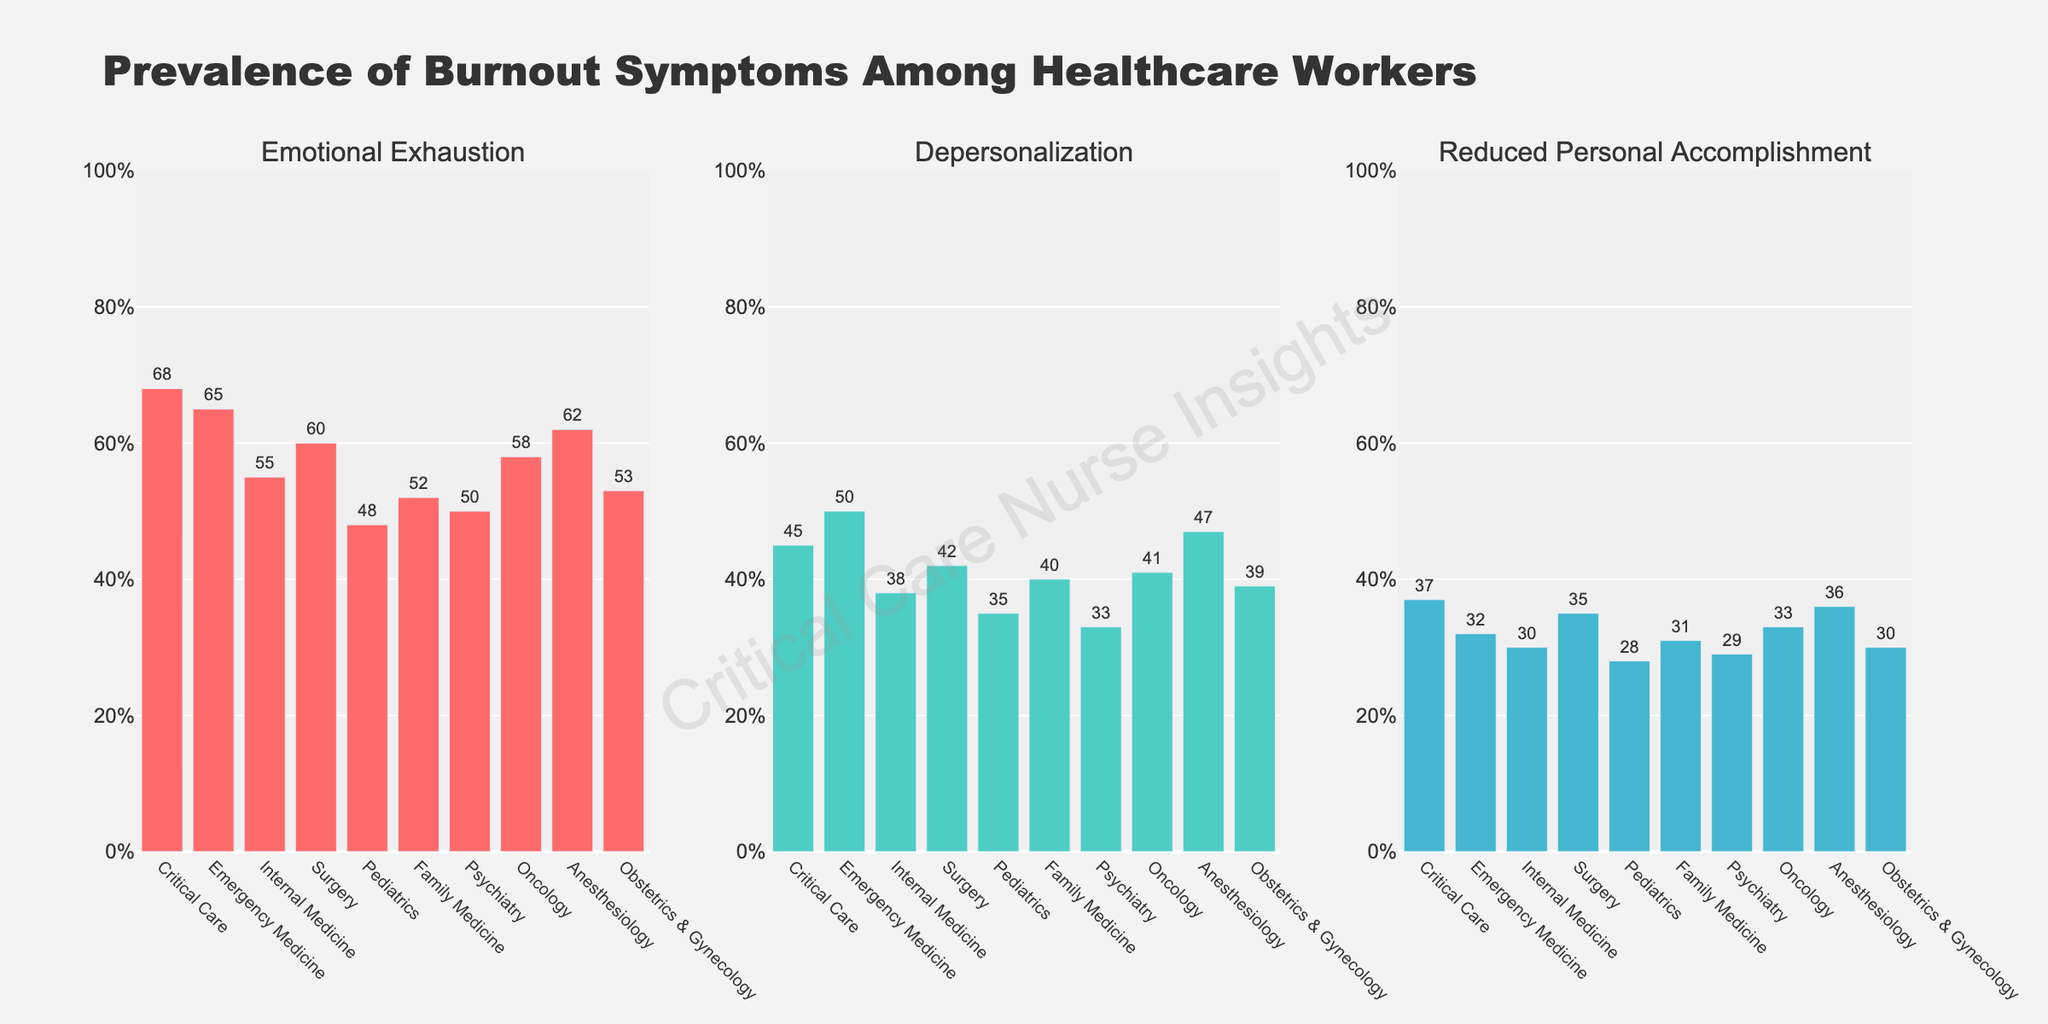What is the title of the figure? The title is located at the top center of the figure and provides a summary of what the figure illustrates.
Answer: Prevalence of Burnout Symptoms Among Healthcare Workers Which specialty shows the highest percentage of emotional exhaustion? By examining the first subplot titled "Emotional Exhaustion," we can identify the highest bar.
Answer: Critical Care How many specialties have a depersonalization percentage of 40% or higher? Look at the second subplot titled "Depersonalization" and count the bars that reach 40% or higher.
Answer: 6 What is the combined percentage of reduced personal accomplishment for Family Medicine and Pediatrics? In the third subplot titled "Reduced Personal Accomplishment," locate the percentages for Family Medicine and Pediatrics and sum them up (31% + 28%).
Answer: 59% Which specialty has a lower percentage of reduced personal accomplishment, Internal Medicine or Anesthesiology? In the third subplot titled "Reduced Personal Accomplishment," compare the heights of the bars for Internal Medicine and Anesthesiology.
Answer: Internal Medicine What is the average percentage of emotional exhaustion across all specialties? Add up all the percentages of emotional exhaustion from the first subplot and divide by the number of specialties ((68 + 65 + 55 + 60 + 48 + 52 + 50 + 58 + 62 + 53) / 10).
Answer: 57.1% Which specialty has the smallest difference between the percentages of emotional exhaustion and depersonalization? For each specialty, subtract the depersonalization percentage from the emotional exhaustion percentage and find the smallest difference. Critical Care is 68 - 45 = 23, Emergency Medicine is 65 - 50 = 15, and so on.
Answer: Emergency Medicine How does the percentage of reduced personal accomplishment in Obstetrics & Gynecology compare with that in Psychiatry? Compare the heights of the bars in the third subplot for Obstetrics & Gynecology (30%) and Psychiatry (29%).
Answer: Higher by 1% Which specialty shows a percentage of emotional exhaustion that is only slightly above 50%? In the first subplot, locate the bar that is just above 50% while comparing among all the specialties.
Answer: Family Medicine What is the median percentage of depersonalization across all specialties? Extract all the percentages from the second subplot, sort them, and find the middle value. The sorted values are 33, 35, 38, 39, 40, 41, 42, 45, 47, 50. The median is the average of the two middle values (40 + 41) / 2.
Answer: 40.5% 